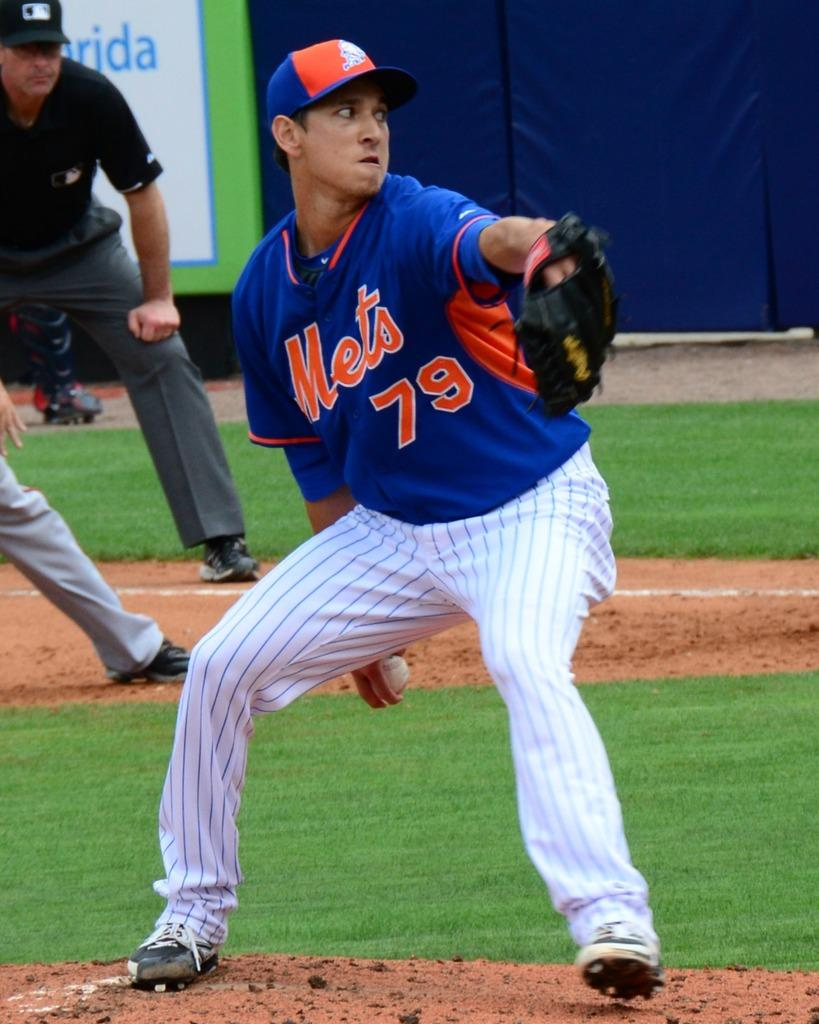<image>
Summarize the visual content of the image. The number 79 mets player is about to pitch the ball. 